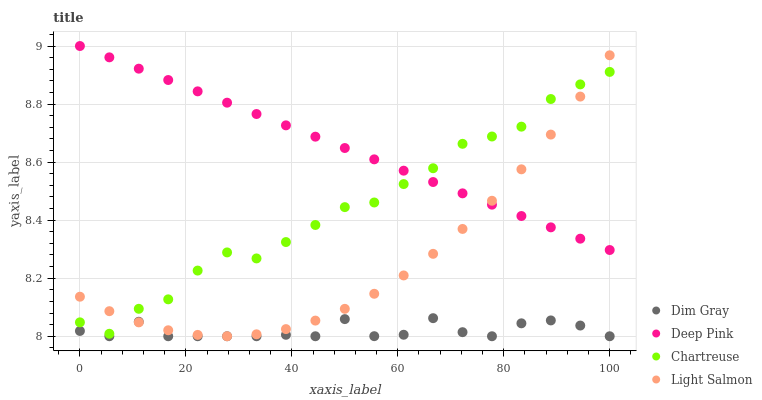Does Dim Gray have the minimum area under the curve?
Answer yes or no. Yes. Does Deep Pink have the maximum area under the curve?
Answer yes or no. Yes. Does Light Salmon have the minimum area under the curve?
Answer yes or no. No. Does Light Salmon have the maximum area under the curve?
Answer yes or no. No. Is Deep Pink the smoothest?
Answer yes or no. Yes. Is Dim Gray the roughest?
Answer yes or no. Yes. Is Light Salmon the smoothest?
Answer yes or no. No. Is Light Salmon the roughest?
Answer yes or no. No. Does Dim Gray have the lowest value?
Answer yes or no. Yes. Does Light Salmon have the lowest value?
Answer yes or no. No. Does Deep Pink have the highest value?
Answer yes or no. Yes. Does Light Salmon have the highest value?
Answer yes or no. No. Is Dim Gray less than Chartreuse?
Answer yes or no. Yes. Is Chartreuse greater than Dim Gray?
Answer yes or no. Yes. Does Light Salmon intersect Chartreuse?
Answer yes or no. Yes. Is Light Salmon less than Chartreuse?
Answer yes or no. No. Is Light Salmon greater than Chartreuse?
Answer yes or no. No. Does Dim Gray intersect Chartreuse?
Answer yes or no. No. 